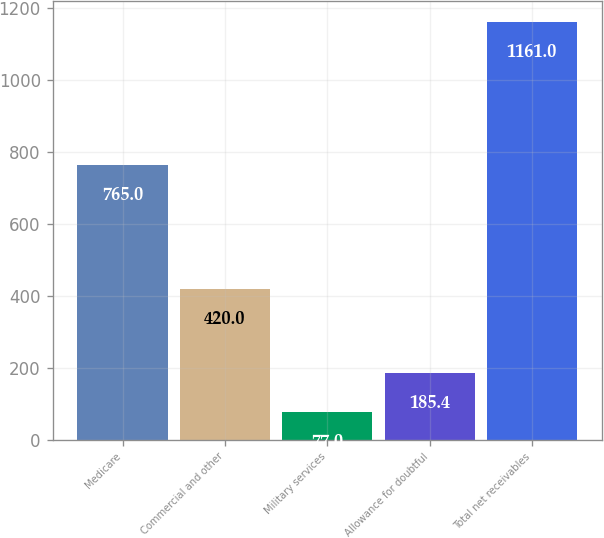<chart> <loc_0><loc_0><loc_500><loc_500><bar_chart><fcel>Medicare<fcel>Commercial and other<fcel>Military services<fcel>Allowance for doubtful<fcel>Total net receivables<nl><fcel>765<fcel>420<fcel>77<fcel>185.4<fcel>1161<nl></chart> 